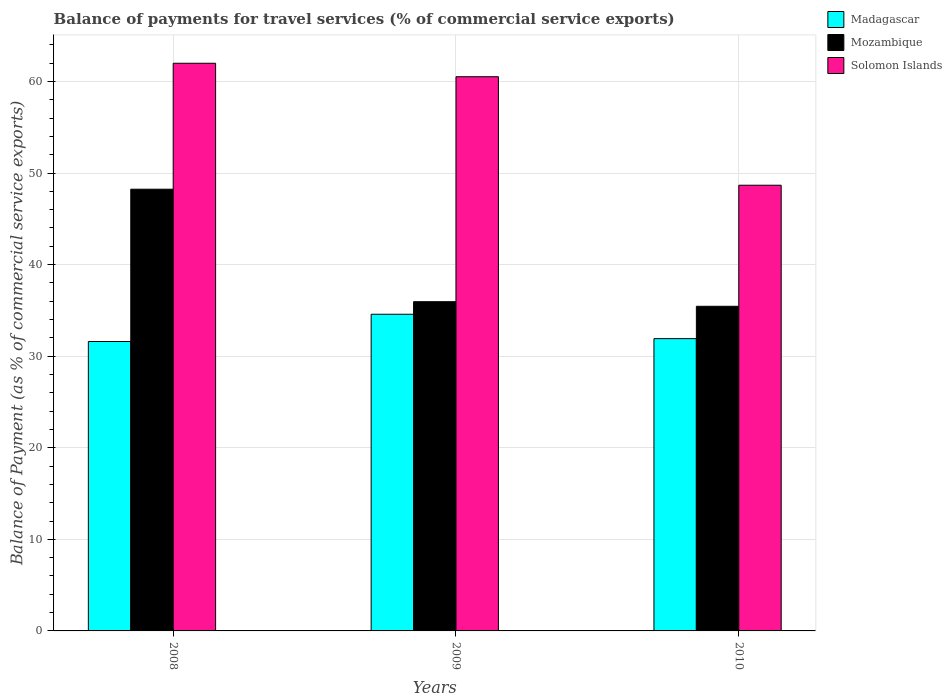How many groups of bars are there?
Offer a terse response. 3. Are the number of bars on each tick of the X-axis equal?
Offer a very short reply. Yes. How many bars are there on the 3rd tick from the left?
Offer a very short reply. 3. How many bars are there on the 2nd tick from the right?
Your response must be concise. 3. What is the balance of payments for travel services in Madagascar in 2010?
Your answer should be very brief. 31.92. Across all years, what is the maximum balance of payments for travel services in Mozambique?
Provide a succinct answer. 48.23. Across all years, what is the minimum balance of payments for travel services in Madagascar?
Provide a short and direct response. 31.6. In which year was the balance of payments for travel services in Solomon Islands minimum?
Your response must be concise. 2010. What is the total balance of payments for travel services in Madagascar in the graph?
Provide a short and direct response. 98.1. What is the difference between the balance of payments for travel services in Madagascar in 2009 and that in 2010?
Offer a very short reply. 2.66. What is the difference between the balance of payments for travel services in Solomon Islands in 2008 and the balance of payments for travel services in Mozambique in 2010?
Your response must be concise. 26.54. What is the average balance of payments for travel services in Madagascar per year?
Your answer should be very brief. 32.7. In the year 2009, what is the difference between the balance of payments for travel services in Madagascar and balance of payments for travel services in Solomon Islands?
Keep it short and to the point. -25.94. In how many years, is the balance of payments for travel services in Mozambique greater than 6 %?
Your response must be concise. 3. What is the ratio of the balance of payments for travel services in Mozambique in 2008 to that in 2010?
Offer a very short reply. 1.36. Is the difference between the balance of payments for travel services in Madagascar in 2008 and 2010 greater than the difference between the balance of payments for travel services in Solomon Islands in 2008 and 2010?
Ensure brevity in your answer.  No. What is the difference between the highest and the second highest balance of payments for travel services in Mozambique?
Your answer should be very brief. 12.28. What is the difference between the highest and the lowest balance of payments for travel services in Madagascar?
Provide a short and direct response. 2.97. In how many years, is the balance of payments for travel services in Madagascar greater than the average balance of payments for travel services in Madagascar taken over all years?
Offer a terse response. 1. What does the 3rd bar from the left in 2010 represents?
Make the answer very short. Solomon Islands. What does the 1st bar from the right in 2008 represents?
Offer a very short reply. Solomon Islands. How many bars are there?
Give a very brief answer. 9. Are all the bars in the graph horizontal?
Give a very brief answer. No. How many years are there in the graph?
Your response must be concise. 3. Does the graph contain grids?
Offer a very short reply. Yes. What is the title of the graph?
Give a very brief answer. Balance of payments for travel services (% of commercial service exports). Does "New Zealand" appear as one of the legend labels in the graph?
Your answer should be very brief. No. What is the label or title of the X-axis?
Provide a short and direct response. Years. What is the label or title of the Y-axis?
Your answer should be compact. Balance of Payment (as % of commercial service exports). What is the Balance of Payment (as % of commercial service exports) of Madagascar in 2008?
Offer a terse response. 31.6. What is the Balance of Payment (as % of commercial service exports) of Mozambique in 2008?
Your answer should be very brief. 48.23. What is the Balance of Payment (as % of commercial service exports) in Solomon Islands in 2008?
Give a very brief answer. 61.99. What is the Balance of Payment (as % of commercial service exports) of Madagascar in 2009?
Keep it short and to the point. 34.58. What is the Balance of Payment (as % of commercial service exports) of Mozambique in 2009?
Ensure brevity in your answer.  35.95. What is the Balance of Payment (as % of commercial service exports) in Solomon Islands in 2009?
Your answer should be compact. 60.51. What is the Balance of Payment (as % of commercial service exports) in Madagascar in 2010?
Your answer should be very brief. 31.92. What is the Balance of Payment (as % of commercial service exports) of Mozambique in 2010?
Offer a very short reply. 35.45. What is the Balance of Payment (as % of commercial service exports) in Solomon Islands in 2010?
Make the answer very short. 48.67. Across all years, what is the maximum Balance of Payment (as % of commercial service exports) in Madagascar?
Your response must be concise. 34.58. Across all years, what is the maximum Balance of Payment (as % of commercial service exports) of Mozambique?
Offer a very short reply. 48.23. Across all years, what is the maximum Balance of Payment (as % of commercial service exports) of Solomon Islands?
Your answer should be very brief. 61.99. Across all years, what is the minimum Balance of Payment (as % of commercial service exports) of Madagascar?
Your response must be concise. 31.6. Across all years, what is the minimum Balance of Payment (as % of commercial service exports) of Mozambique?
Your response must be concise. 35.45. Across all years, what is the minimum Balance of Payment (as % of commercial service exports) in Solomon Islands?
Keep it short and to the point. 48.67. What is the total Balance of Payment (as % of commercial service exports) in Madagascar in the graph?
Offer a terse response. 98.1. What is the total Balance of Payment (as % of commercial service exports) of Mozambique in the graph?
Provide a succinct answer. 119.63. What is the total Balance of Payment (as % of commercial service exports) of Solomon Islands in the graph?
Offer a terse response. 171.17. What is the difference between the Balance of Payment (as % of commercial service exports) of Madagascar in 2008 and that in 2009?
Your answer should be compact. -2.97. What is the difference between the Balance of Payment (as % of commercial service exports) in Mozambique in 2008 and that in 2009?
Provide a short and direct response. 12.28. What is the difference between the Balance of Payment (as % of commercial service exports) of Solomon Islands in 2008 and that in 2009?
Offer a terse response. 1.47. What is the difference between the Balance of Payment (as % of commercial service exports) in Madagascar in 2008 and that in 2010?
Give a very brief answer. -0.31. What is the difference between the Balance of Payment (as % of commercial service exports) of Mozambique in 2008 and that in 2010?
Give a very brief answer. 12.79. What is the difference between the Balance of Payment (as % of commercial service exports) in Solomon Islands in 2008 and that in 2010?
Make the answer very short. 13.32. What is the difference between the Balance of Payment (as % of commercial service exports) in Madagascar in 2009 and that in 2010?
Offer a very short reply. 2.66. What is the difference between the Balance of Payment (as % of commercial service exports) in Mozambique in 2009 and that in 2010?
Provide a succinct answer. 0.5. What is the difference between the Balance of Payment (as % of commercial service exports) in Solomon Islands in 2009 and that in 2010?
Give a very brief answer. 11.85. What is the difference between the Balance of Payment (as % of commercial service exports) in Madagascar in 2008 and the Balance of Payment (as % of commercial service exports) in Mozambique in 2009?
Your answer should be compact. -4.35. What is the difference between the Balance of Payment (as % of commercial service exports) in Madagascar in 2008 and the Balance of Payment (as % of commercial service exports) in Solomon Islands in 2009?
Provide a short and direct response. -28.91. What is the difference between the Balance of Payment (as % of commercial service exports) of Mozambique in 2008 and the Balance of Payment (as % of commercial service exports) of Solomon Islands in 2009?
Provide a succinct answer. -12.28. What is the difference between the Balance of Payment (as % of commercial service exports) of Madagascar in 2008 and the Balance of Payment (as % of commercial service exports) of Mozambique in 2010?
Provide a short and direct response. -3.84. What is the difference between the Balance of Payment (as % of commercial service exports) of Madagascar in 2008 and the Balance of Payment (as % of commercial service exports) of Solomon Islands in 2010?
Make the answer very short. -17.06. What is the difference between the Balance of Payment (as % of commercial service exports) in Mozambique in 2008 and the Balance of Payment (as % of commercial service exports) in Solomon Islands in 2010?
Provide a short and direct response. -0.43. What is the difference between the Balance of Payment (as % of commercial service exports) of Madagascar in 2009 and the Balance of Payment (as % of commercial service exports) of Mozambique in 2010?
Give a very brief answer. -0.87. What is the difference between the Balance of Payment (as % of commercial service exports) in Madagascar in 2009 and the Balance of Payment (as % of commercial service exports) in Solomon Islands in 2010?
Ensure brevity in your answer.  -14.09. What is the difference between the Balance of Payment (as % of commercial service exports) of Mozambique in 2009 and the Balance of Payment (as % of commercial service exports) of Solomon Islands in 2010?
Provide a succinct answer. -12.72. What is the average Balance of Payment (as % of commercial service exports) of Madagascar per year?
Give a very brief answer. 32.7. What is the average Balance of Payment (as % of commercial service exports) in Mozambique per year?
Your response must be concise. 39.88. What is the average Balance of Payment (as % of commercial service exports) in Solomon Islands per year?
Offer a terse response. 57.06. In the year 2008, what is the difference between the Balance of Payment (as % of commercial service exports) of Madagascar and Balance of Payment (as % of commercial service exports) of Mozambique?
Your answer should be very brief. -16.63. In the year 2008, what is the difference between the Balance of Payment (as % of commercial service exports) in Madagascar and Balance of Payment (as % of commercial service exports) in Solomon Islands?
Offer a terse response. -30.38. In the year 2008, what is the difference between the Balance of Payment (as % of commercial service exports) of Mozambique and Balance of Payment (as % of commercial service exports) of Solomon Islands?
Your answer should be very brief. -13.75. In the year 2009, what is the difference between the Balance of Payment (as % of commercial service exports) in Madagascar and Balance of Payment (as % of commercial service exports) in Mozambique?
Your answer should be very brief. -1.37. In the year 2009, what is the difference between the Balance of Payment (as % of commercial service exports) of Madagascar and Balance of Payment (as % of commercial service exports) of Solomon Islands?
Your response must be concise. -25.94. In the year 2009, what is the difference between the Balance of Payment (as % of commercial service exports) of Mozambique and Balance of Payment (as % of commercial service exports) of Solomon Islands?
Your response must be concise. -24.56. In the year 2010, what is the difference between the Balance of Payment (as % of commercial service exports) in Madagascar and Balance of Payment (as % of commercial service exports) in Mozambique?
Your answer should be compact. -3.53. In the year 2010, what is the difference between the Balance of Payment (as % of commercial service exports) of Madagascar and Balance of Payment (as % of commercial service exports) of Solomon Islands?
Keep it short and to the point. -16.75. In the year 2010, what is the difference between the Balance of Payment (as % of commercial service exports) in Mozambique and Balance of Payment (as % of commercial service exports) in Solomon Islands?
Give a very brief answer. -13.22. What is the ratio of the Balance of Payment (as % of commercial service exports) of Madagascar in 2008 to that in 2009?
Provide a succinct answer. 0.91. What is the ratio of the Balance of Payment (as % of commercial service exports) in Mozambique in 2008 to that in 2009?
Your answer should be very brief. 1.34. What is the ratio of the Balance of Payment (as % of commercial service exports) in Solomon Islands in 2008 to that in 2009?
Ensure brevity in your answer.  1.02. What is the ratio of the Balance of Payment (as % of commercial service exports) in Madagascar in 2008 to that in 2010?
Ensure brevity in your answer.  0.99. What is the ratio of the Balance of Payment (as % of commercial service exports) in Mozambique in 2008 to that in 2010?
Ensure brevity in your answer.  1.36. What is the ratio of the Balance of Payment (as % of commercial service exports) of Solomon Islands in 2008 to that in 2010?
Your answer should be compact. 1.27. What is the ratio of the Balance of Payment (as % of commercial service exports) of Madagascar in 2009 to that in 2010?
Keep it short and to the point. 1.08. What is the ratio of the Balance of Payment (as % of commercial service exports) in Mozambique in 2009 to that in 2010?
Your response must be concise. 1.01. What is the ratio of the Balance of Payment (as % of commercial service exports) of Solomon Islands in 2009 to that in 2010?
Provide a succinct answer. 1.24. What is the difference between the highest and the second highest Balance of Payment (as % of commercial service exports) in Madagascar?
Ensure brevity in your answer.  2.66. What is the difference between the highest and the second highest Balance of Payment (as % of commercial service exports) of Mozambique?
Your answer should be very brief. 12.28. What is the difference between the highest and the second highest Balance of Payment (as % of commercial service exports) in Solomon Islands?
Ensure brevity in your answer.  1.47. What is the difference between the highest and the lowest Balance of Payment (as % of commercial service exports) in Madagascar?
Provide a succinct answer. 2.97. What is the difference between the highest and the lowest Balance of Payment (as % of commercial service exports) of Mozambique?
Your answer should be compact. 12.79. What is the difference between the highest and the lowest Balance of Payment (as % of commercial service exports) in Solomon Islands?
Provide a short and direct response. 13.32. 